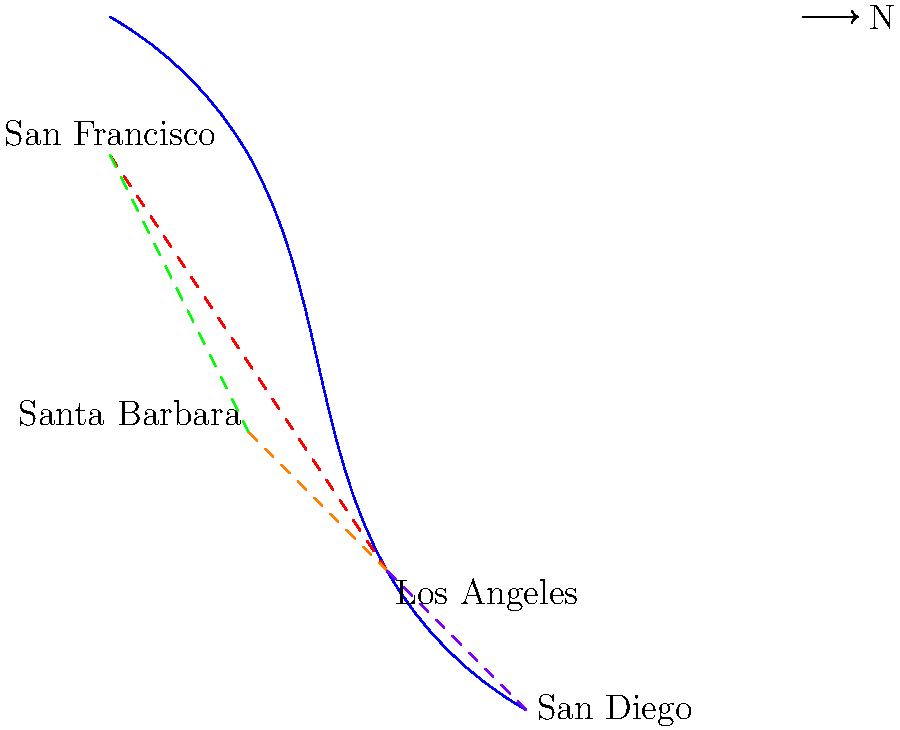Based on the map of ancient Californian trade routes, which city appears to be the most central hub for trade, connecting to the most other locations? How might this positioning have influenced its importance in the region? To determine the most central hub for trade, we need to analyze the connections between cities:

1. San Francisco:
   - Connected to Los Angeles
   - Connected to Santa Barbara
   Total connections: 2

2. Los Angeles:
   - Connected to San Francisco
   - Connected to Santa Barbara
   - Connected to San Diego
   Total connections: 3

3. San Diego:
   - Connected to Los Angeles
   Total connections: 1

4. Santa Barbara:
   - Connected to San Francisco
   - Connected to Los Angeles
   Total connections: 2

Los Angeles has the most connections (3) to other cities, making it the most central hub for trade.

The importance of Los Angeles in the region would likely have been significant due to its central position:

1. Access to resources: It could have received goods from multiple sources, increasing variety and abundance.
2. Cultural exchange: More connections meant more opportunities for cultural diffusion and knowledge sharing.
3. Economic power: Control over multiple trade routes could have led to increased wealth and influence.
4. Population growth: The influx of goods and people would likely have supported a larger population.
5. Political importance: Its strategic position could have made it a key player in regional alliances and conflicts.

This central position would have made Los Angeles a crucial nexus for economic, cultural, and potentially political activities in ancient California.
Answer: Los Angeles; central position increased access to resources, cultural exchange, economic power, population growth, and political importance. 